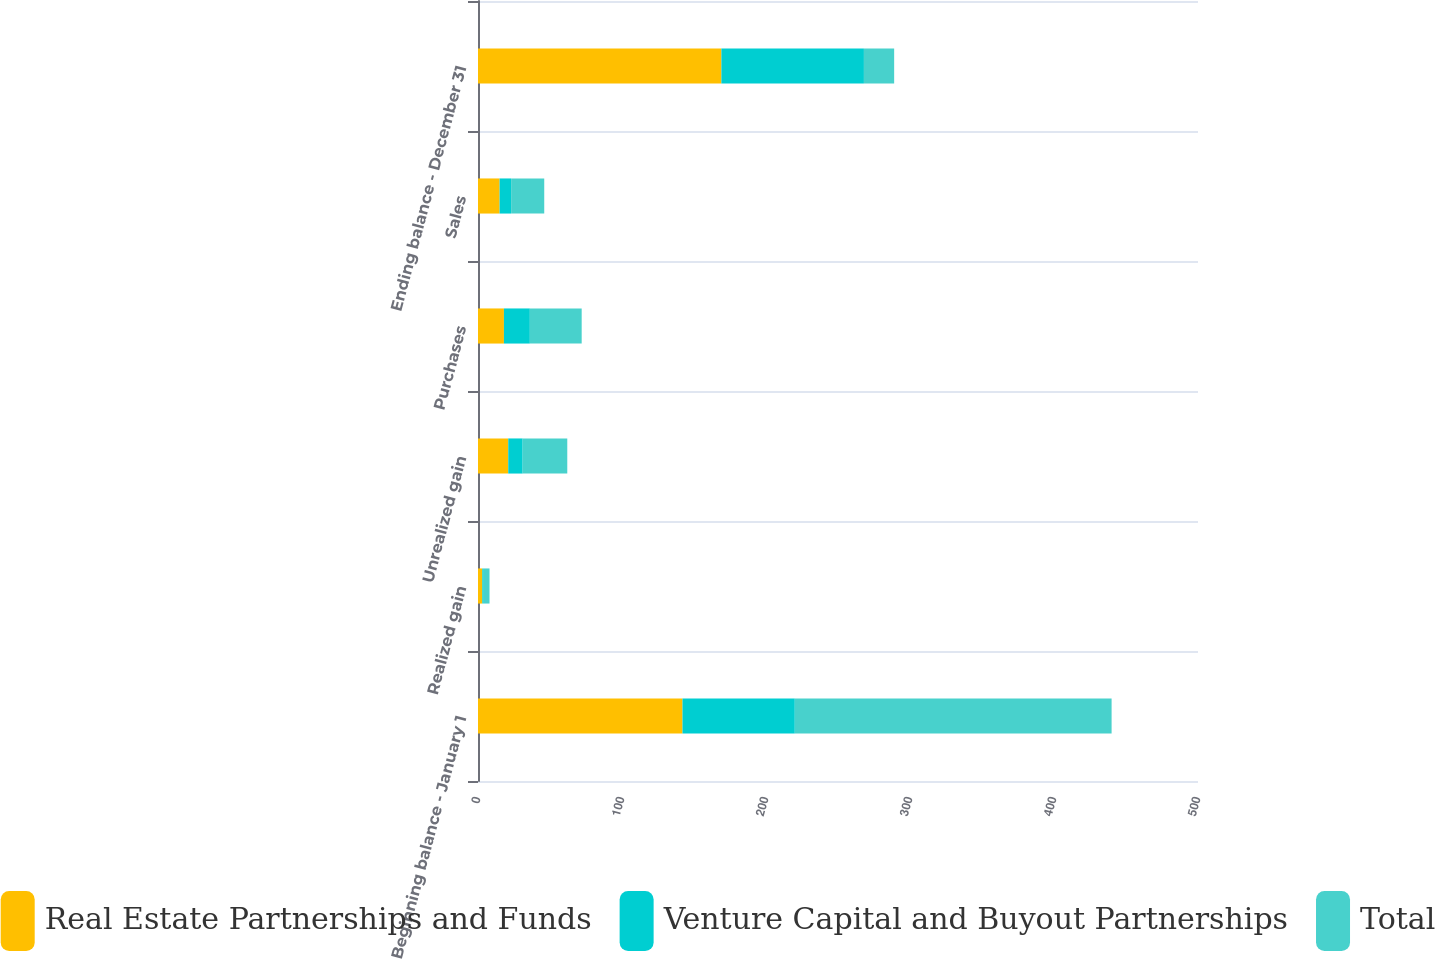Convert chart. <chart><loc_0><loc_0><loc_500><loc_500><stacked_bar_chart><ecel><fcel>Beginning balance - January 1<fcel>Realized gain<fcel>Unrealized gain<fcel>Purchases<fcel>Sales<fcel>Ending balance - December 31<nl><fcel>Real Estate Partnerships and Funds<fcel>142<fcel>3<fcel>21<fcel>18<fcel>15<fcel>169<nl><fcel>Venture Capital and Buyout Partnerships<fcel>78<fcel>1<fcel>10<fcel>18<fcel>8<fcel>99<nl><fcel>Total<fcel>220<fcel>4<fcel>31<fcel>36<fcel>23<fcel>21<nl></chart> 